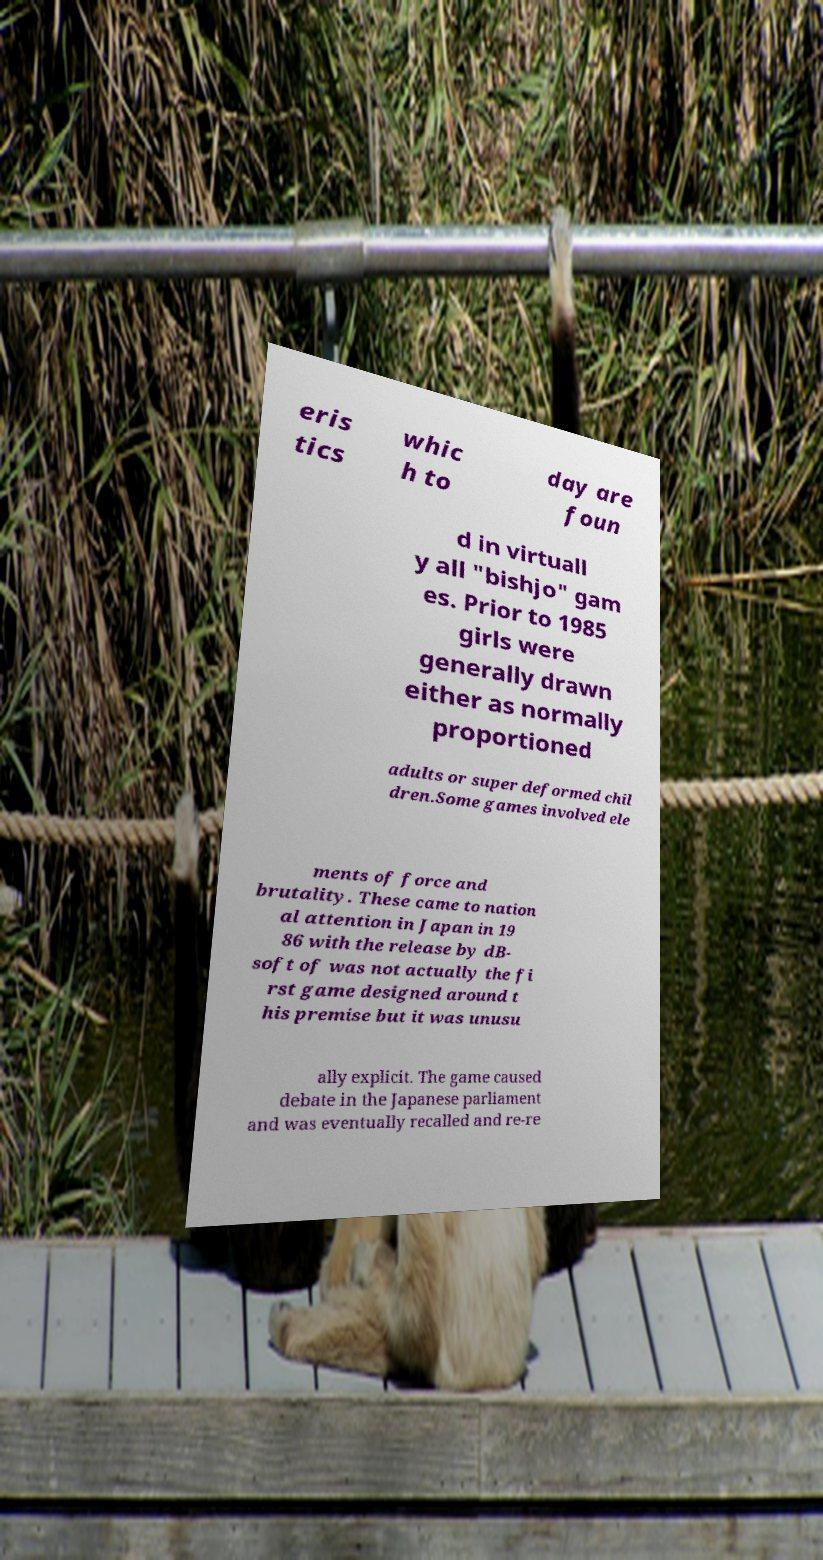Please identify and transcribe the text found in this image. eris tics whic h to day are foun d in virtuall y all "bishjo" gam es. Prior to 1985 girls were generally drawn either as normally proportioned adults or super deformed chil dren.Some games involved ele ments of force and brutality. These came to nation al attention in Japan in 19 86 with the release by dB- soft of was not actually the fi rst game designed around t his premise but it was unusu ally explicit. The game caused debate in the Japanese parliament and was eventually recalled and re-re 